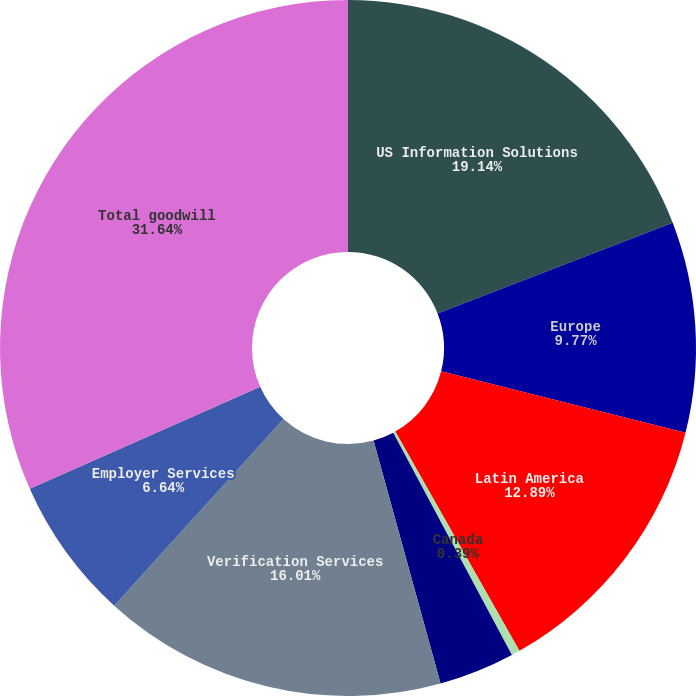<chart> <loc_0><loc_0><loc_500><loc_500><pie_chart><fcel>US Information Solutions<fcel>Europe<fcel>Latin America<fcel>Canada<fcel>Personal Solutions<fcel>Verification Services<fcel>Employer Services<fcel>Total goodwill<nl><fcel>19.14%<fcel>9.77%<fcel>12.89%<fcel>0.39%<fcel>3.52%<fcel>16.01%<fcel>6.64%<fcel>31.63%<nl></chart> 